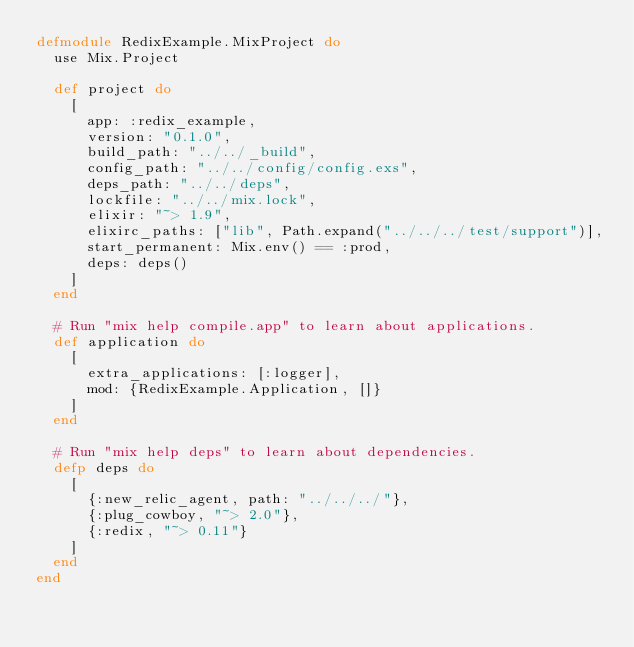Convert code to text. <code><loc_0><loc_0><loc_500><loc_500><_Elixir_>defmodule RedixExample.MixProject do
  use Mix.Project

  def project do
    [
      app: :redix_example,
      version: "0.1.0",
      build_path: "../../_build",
      config_path: "../../config/config.exs",
      deps_path: "../../deps",
      lockfile: "../../mix.lock",
      elixir: "~> 1.9",
      elixirc_paths: ["lib", Path.expand("../../../test/support")],
      start_permanent: Mix.env() == :prod,
      deps: deps()
    ]
  end

  # Run "mix help compile.app" to learn about applications.
  def application do
    [
      extra_applications: [:logger],
      mod: {RedixExample.Application, []}
    ]
  end

  # Run "mix help deps" to learn about dependencies.
  defp deps do
    [
      {:new_relic_agent, path: "../../../"},
      {:plug_cowboy, "~> 2.0"},
      {:redix, "~> 0.11"}
    ]
  end
end
</code> 